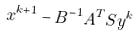Convert formula to latex. <formula><loc_0><loc_0><loc_500><loc_500>x ^ { k + 1 } - B ^ { - 1 } A ^ { T } S y ^ { k }</formula> 